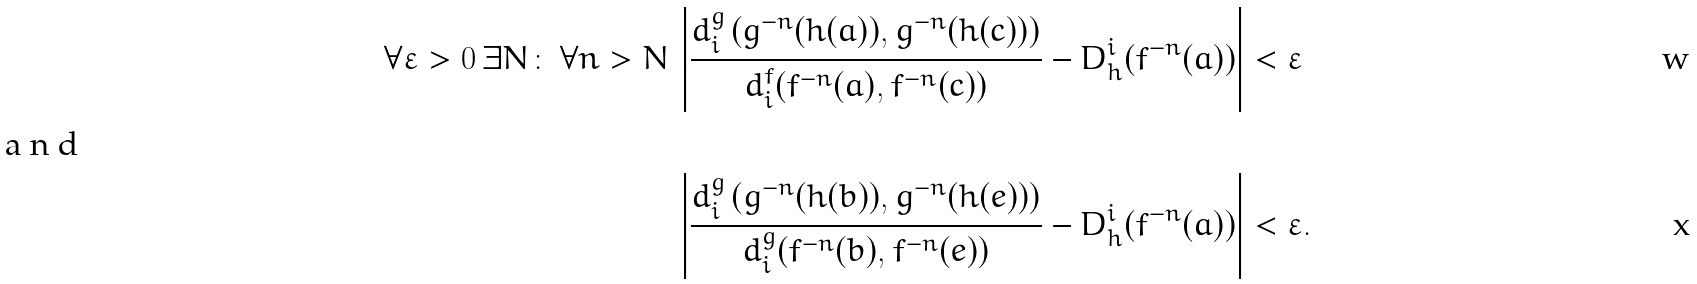<formula> <loc_0><loc_0><loc_500><loc_500>\forall \varepsilon > 0 \, \exists N \colon \, \forall n > N \, \left | \frac { d _ { i } ^ { g } \left ( g ^ { - n } ( h ( a ) ) , g ^ { - n } ( h ( c ) ) \right ) } { d _ { i } ^ { f } ( f ^ { - n } ( a ) , f ^ { - n } ( c ) ) } - D _ { h } ^ { i } ( f ^ { - n } ( a ) ) \right | & < \varepsilon \\ \intertext { a n d } \, \left | \frac { d _ { i } ^ { g } \left ( g ^ { - n } ( h ( b ) ) , g ^ { - n } ( h ( e ) ) \right ) } { d _ { i } ^ { g } ( f ^ { - n } ( b ) , f ^ { - n } ( e ) ) } - D _ { h } ^ { i } ( f ^ { - n } ( a ) ) \right | & < \varepsilon .</formula> 